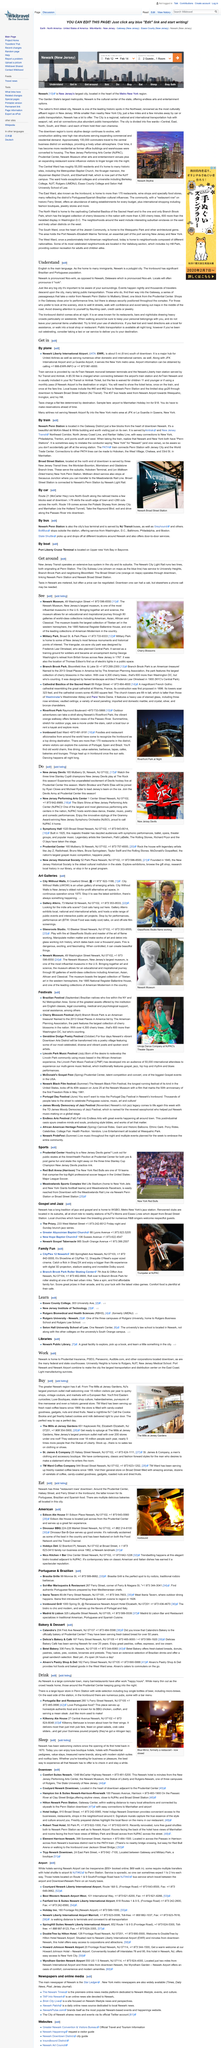Draw attention to some important aspects in this diagram. The fee is waived for children 11 and younger or if using a monthly pass. According to the "Get in" section of the Newark Liberty International Airport, it serves the New York metropolitan area, along with JFK International Airport and La Guardia Airport. Upon connecting between the airport's train station and AirTrain Newark, a fee of $5.50 is charged for this service. 